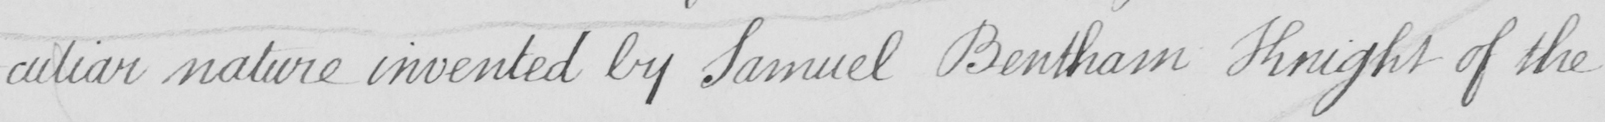What is written in this line of handwriting? -culiar nature invented by Samuel Bentham Knight of the 